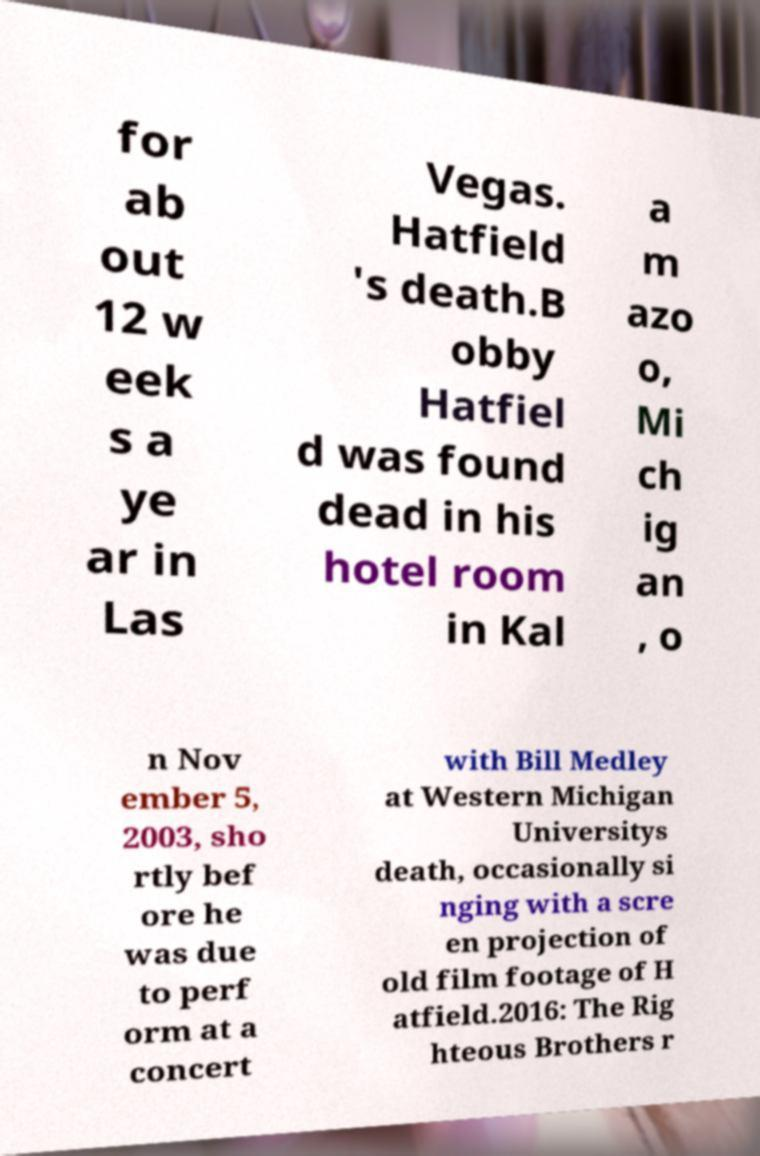Please read and relay the text visible in this image. What does it say? for ab out 12 w eek s a ye ar in Las Vegas. Hatfield 's death.B obby Hatfiel d was found dead in his hotel room in Kal a m azo o, Mi ch ig an , o n Nov ember 5, 2003, sho rtly bef ore he was due to perf orm at a concert with Bill Medley at Western Michigan Universitys death, occasionally si nging with a scre en projection of old film footage of H atfield.2016: The Rig hteous Brothers r 